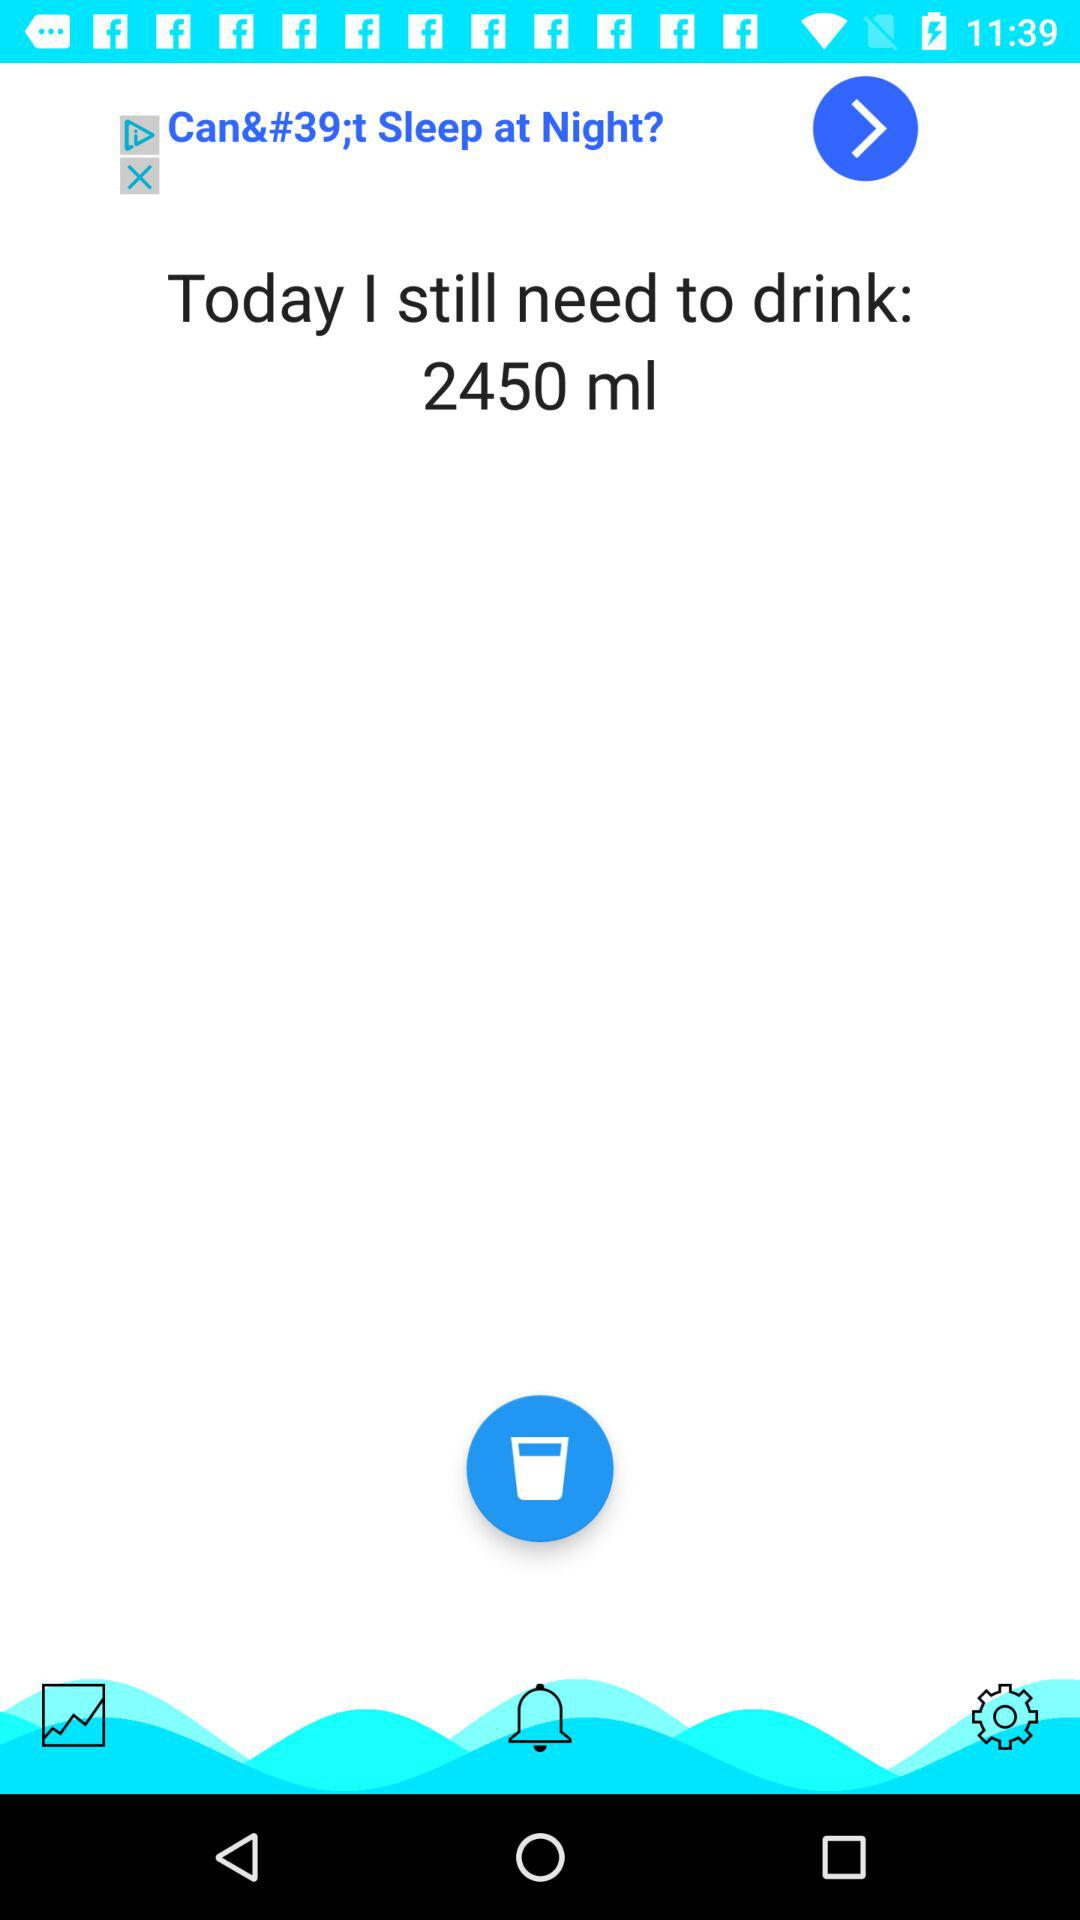What is the quantity of water displayed on the screen? The quantity of water displayed on the screen is 2450 ml. 